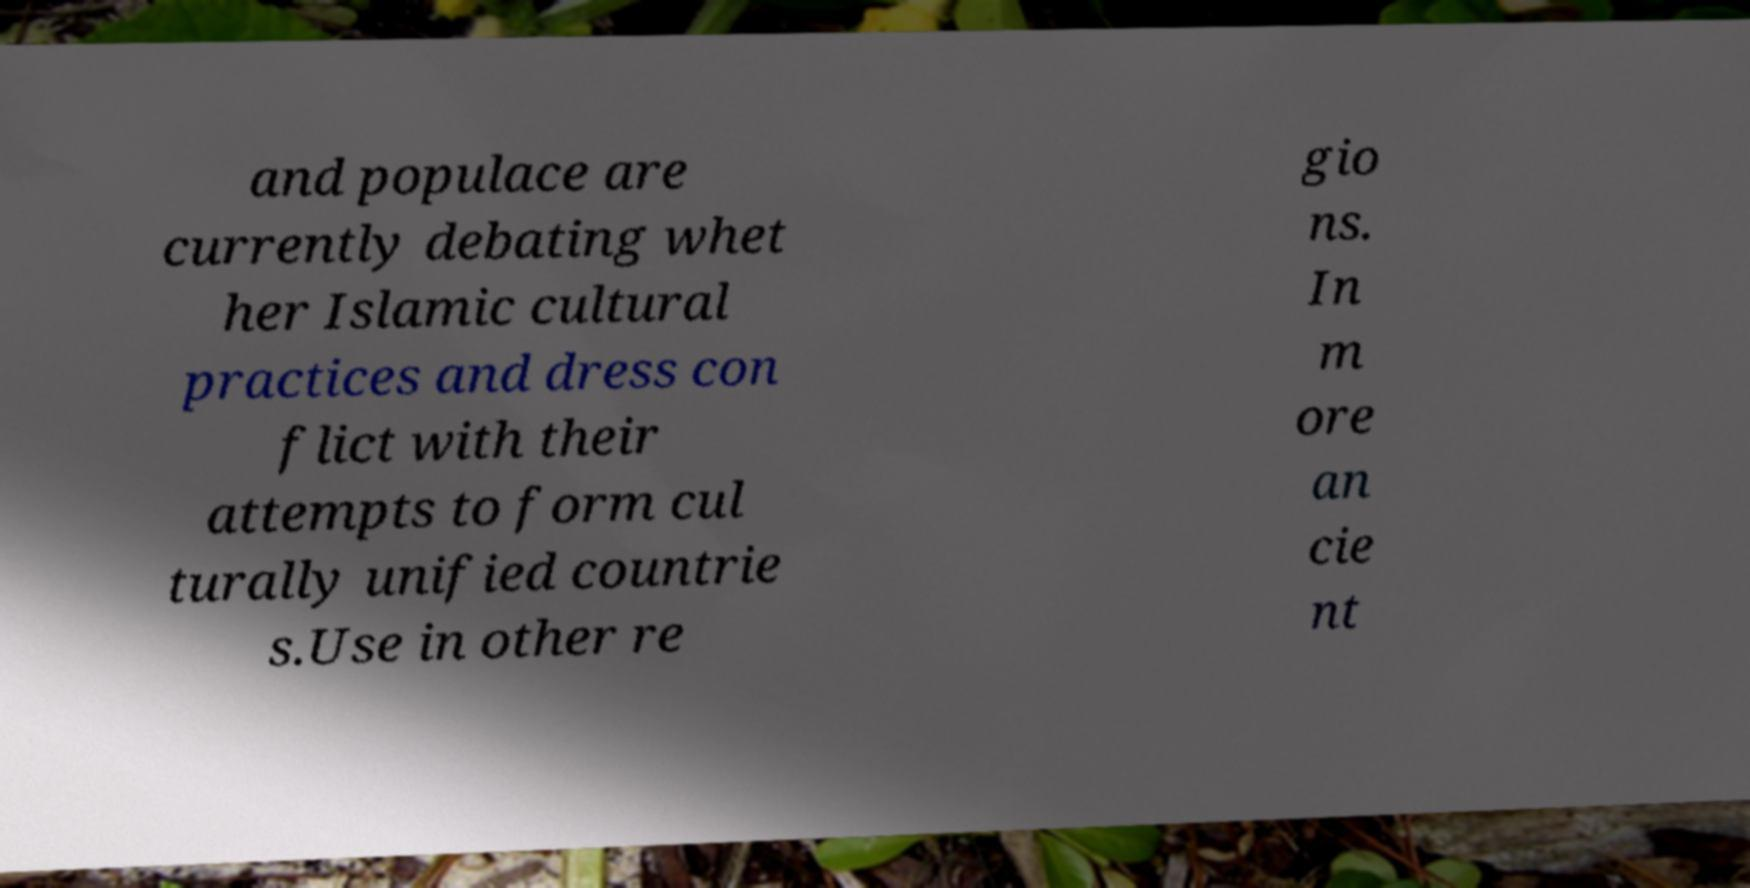Please identify and transcribe the text found in this image. and populace are currently debating whet her Islamic cultural practices and dress con flict with their attempts to form cul turally unified countrie s.Use in other re gio ns. In m ore an cie nt 